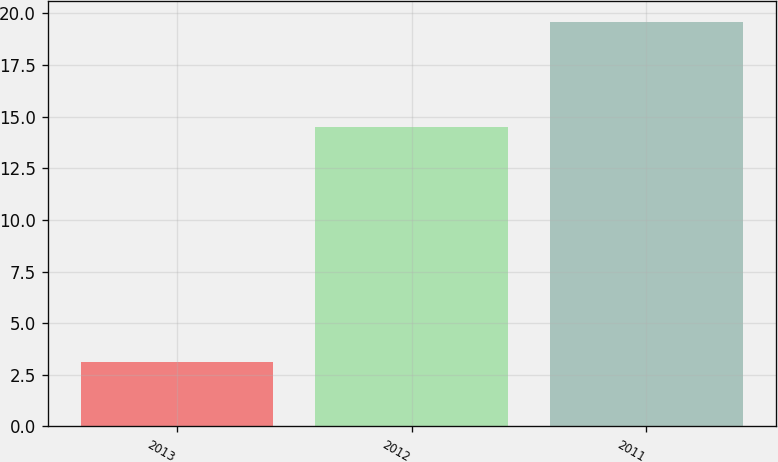<chart> <loc_0><loc_0><loc_500><loc_500><bar_chart><fcel>2013<fcel>2012<fcel>2011<nl><fcel>3.1<fcel>14.5<fcel>19.6<nl></chart> 